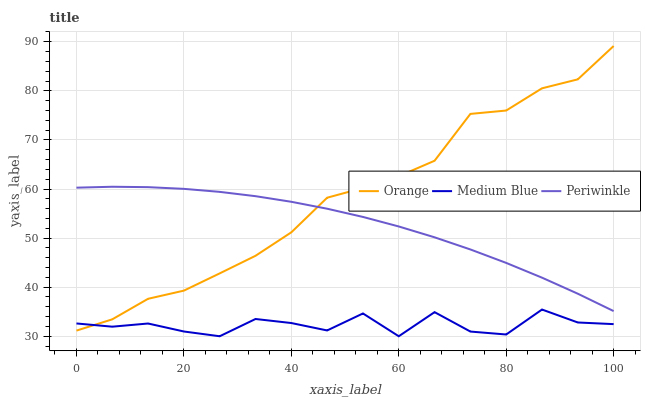Does Medium Blue have the minimum area under the curve?
Answer yes or no. Yes. Does Orange have the maximum area under the curve?
Answer yes or no. Yes. Does Periwinkle have the minimum area under the curve?
Answer yes or no. No. Does Periwinkle have the maximum area under the curve?
Answer yes or no. No. Is Periwinkle the smoothest?
Answer yes or no. Yes. Is Medium Blue the roughest?
Answer yes or no. Yes. Is Medium Blue the smoothest?
Answer yes or no. No. Is Periwinkle the roughest?
Answer yes or no. No. Does Medium Blue have the lowest value?
Answer yes or no. Yes. Does Periwinkle have the lowest value?
Answer yes or no. No. Does Orange have the highest value?
Answer yes or no. Yes. Does Periwinkle have the highest value?
Answer yes or no. No. Is Medium Blue less than Periwinkle?
Answer yes or no. Yes. Is Periwinkle greater than Medium Blue?
Answer yes or no. Yes. Does Periwinkle intersect Orange?
Answer yes or no. Yes. Is Periwinkle less than Orange?
Answer yes or no. No. Is Periwinkle greater than Orange?
Answer yes or no. No. Does Medium Blue intersect Periwinkle?
Answer yes or no. No. 